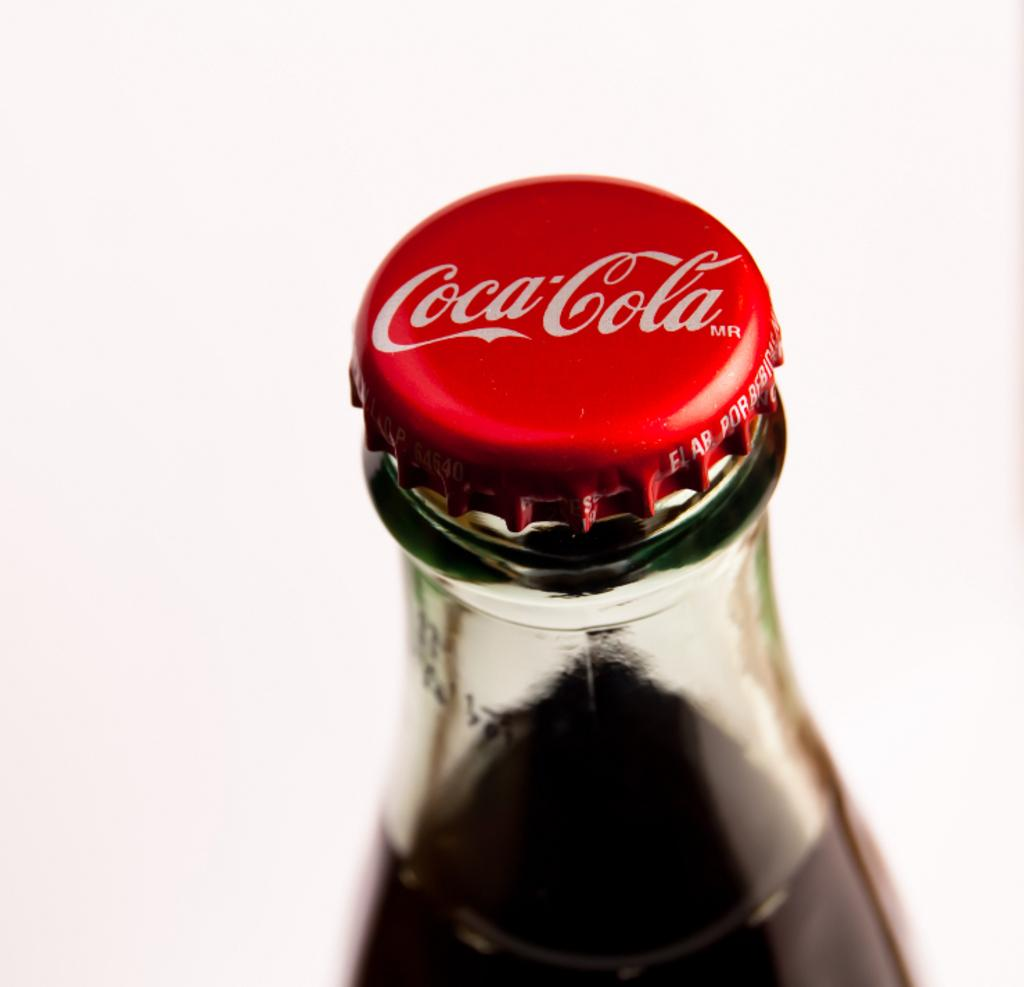What type of bottle is visible in the image? There is a Coca-Cola bottle in the image. What is inside the Coca-Cola bottle? There is a drink inside the Coca-Cola bottle. What type of horn can be seen on the Coca-Cola bottle in the image? There is no horn present on the Coca-Cola bottle in the image. 